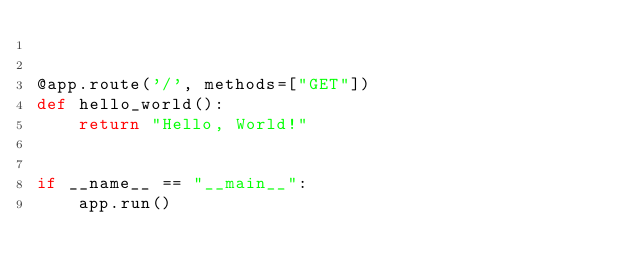<code> <loc_0><loc_0><loc_500><loc_500><_Python_>

@app.route('/', methods=["GET"])
def hello_world():
    return "Hello, World!"


if __name__ == "__main__":
    app.run()
</code> 